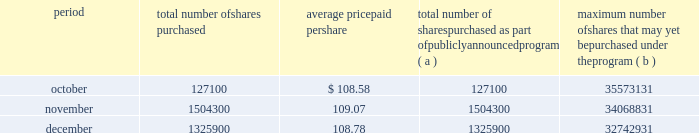Issuer purchases of equity securities the table provides information about our repurchases of common stock during the three-month period ended december 31 , 2007 .
Period total number of shares purchased average price paid per total number of shares purchased as part of publicly announced program ( a ) maximum number of shares that may yet be purchased under the program ( b ) .
( a ) we repurchased a total of 2957300 shares of our common stock during the quarter ended december 31 , 2007 under a share repurchase program that we announced in october 2002 .
( b ) our board of directors has approved a share repurchase program for the repurchase of up to 128 million shares of our common stock from time-to-time , including 20 million shares approved for repurchase by our board of directors in september 2007 .
Under the program , management has discretion to determine the number and price of the shares to be repurchased , and the timing of any repurchases , in compliance with applicable law and regulation .
As of december 31 , 2007 , we had repurchased a total of 95.3 million shares under the program .
In 2007 , we did not make any unregistered sales of equity securities. .
As of december 2007 what was the percent of the shares outstanding of the authorized repurchase by the board of directors in september 2007? 
Computations: (128 - 95.3)
Answer: 32.7. 